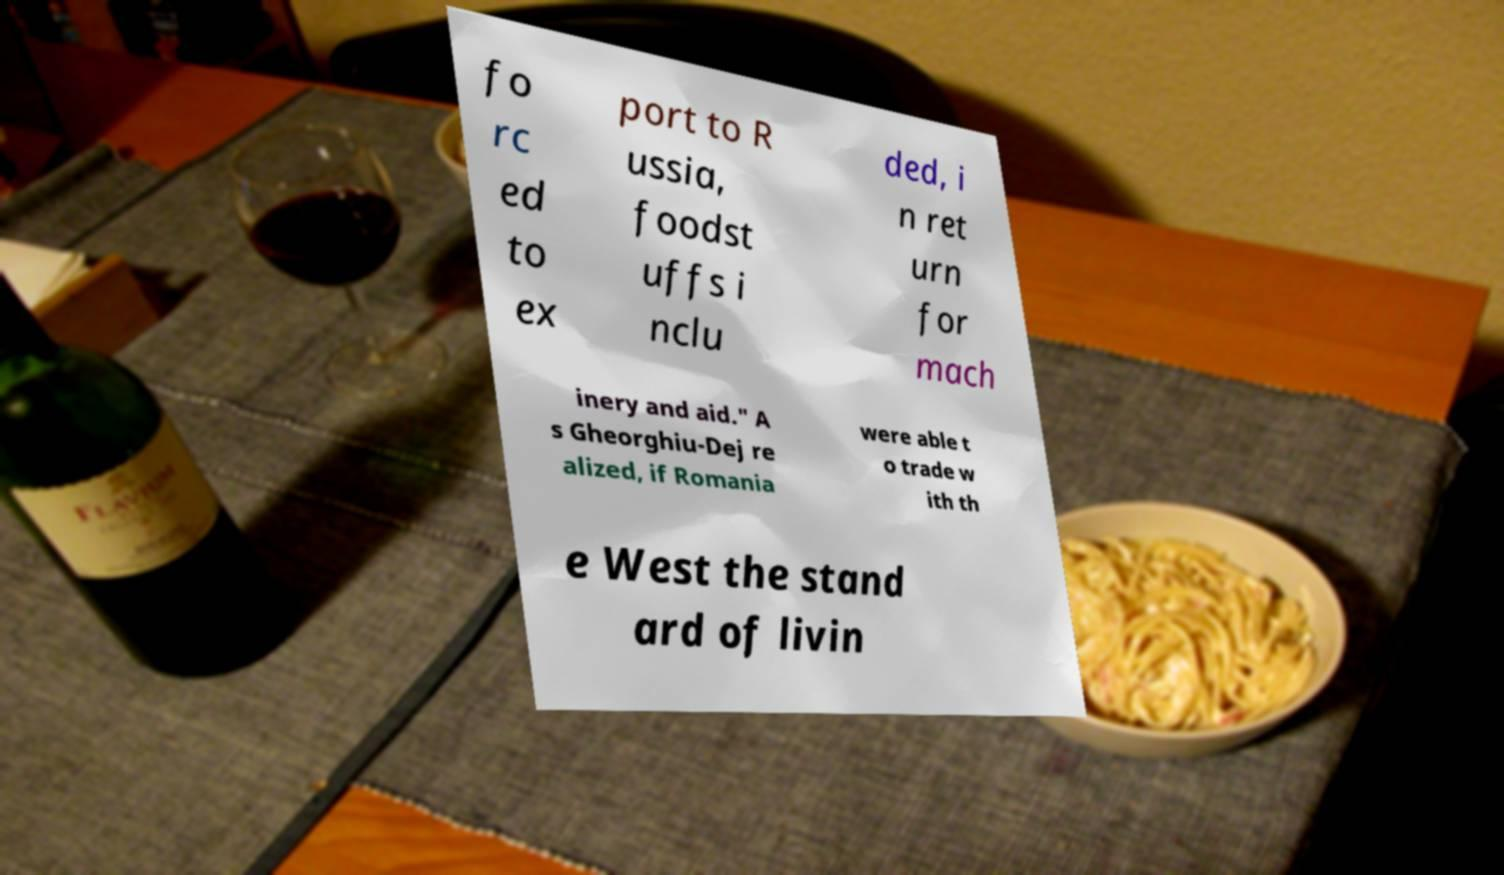There's text embedded in this image that I need extracted. Can you transcribe it verbatim? fo rc ed to ex port to R ussia, foodst uffs i nclu ded, i n ret urn for mach inery and aid." A s Gheorghiu-Dej re alized, if Romania were able t o trade w ith th e West the stand ard of livin 